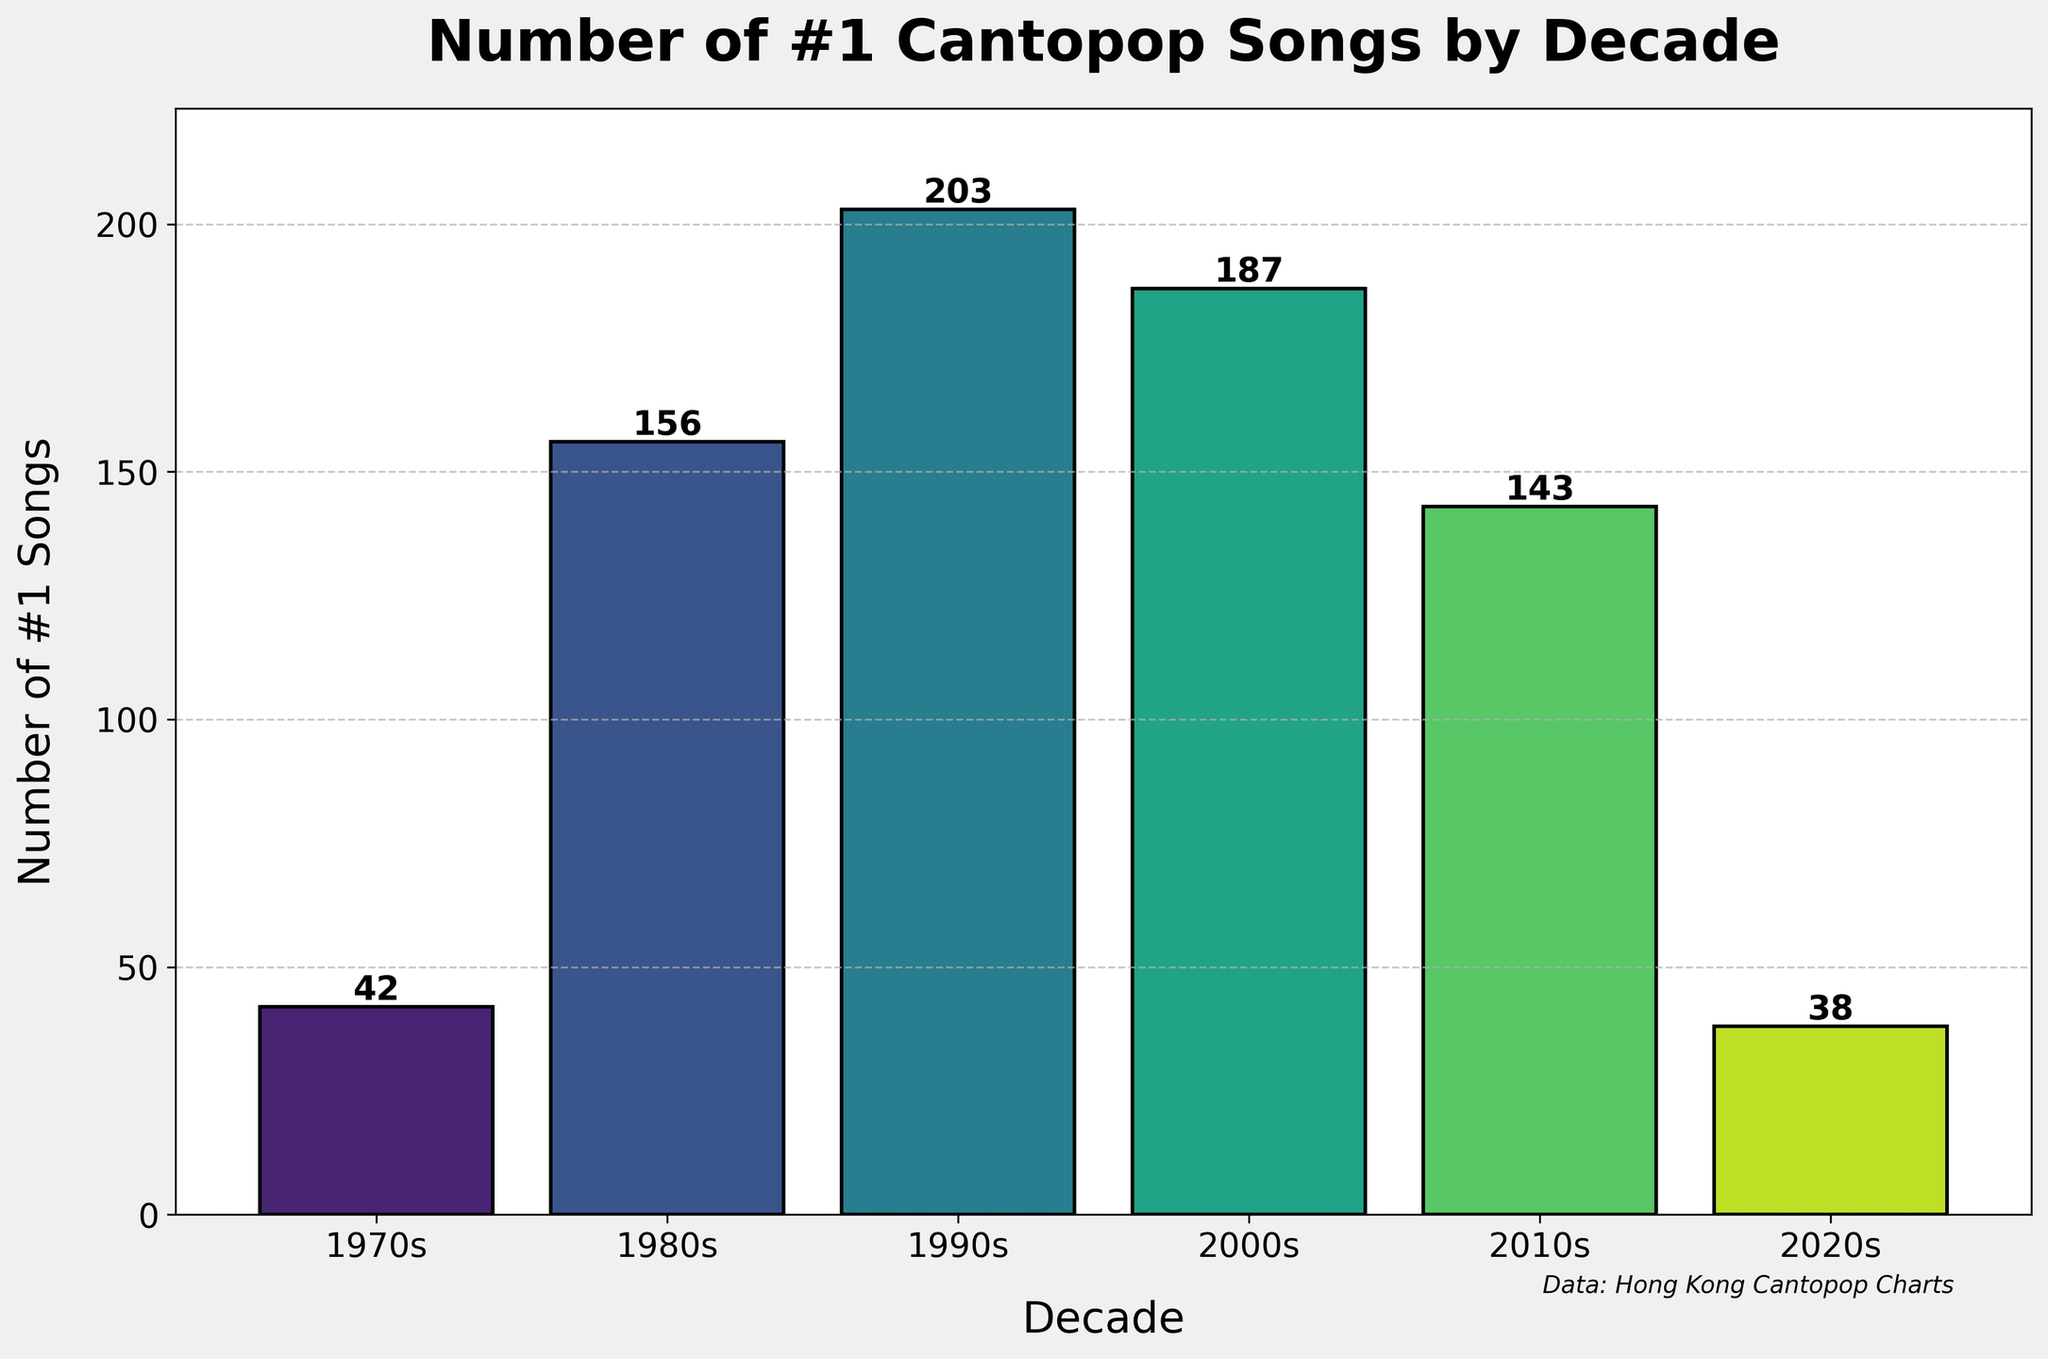Which decade had the highest number of #1 Cantopop songs? By looking at the heights of the bars, the tallest bar corresponds to the 1990s, indicating that this decade had the highest number of #1 Cantopop songs.
Answer: 1990s How many more #1 Cantopop songs were there in the 2000s compared to the 2010s? The number of #1 Cantopop songs in the 2000s is 187 and in the 2010s is 143. The difference is 187 - 143.
Answer: 44 What is the total number of #1 Cantopop songs in the 1970s, 1980s, and 1990s combined? Summing up the numbers: 42 (1970s) + 156 (1980s) + 203 (1990s).
Answer: 401 Which decade saw a greater decline in the number of #1 Cantopop songs, from the 1990s to the 2000s or from the 2000s to the 2010s? The decline from the 1990s to the 2000s is 203 - 187 = 16. The decline from the 2000s to the 2010s is 187 - 143 = 44.
Answer: From the 2000s to the 2010s What is the average number of #1 Cantopop songs per decade from the 1970s to the 2010s? Adding the numbers from each decade and dividing by the number of decades: (42 + 156 + 203 + 187 + 143) / 5.
Answer: 146.2 How many fewer #1 Cantopop songs were there in the 2020s compared to the decade with the second highest number of #1 songs? The second highest number of #1 songs is in the 2000s with 187 songs. The number in the 2020s is 38. The difference is 187 - 38.
Answer: 149 Compare the number of #1 Cantopop songs in the 1970s and the 2020s. Which decade had fewer, and by how much? The number in the 1970s is 42 and in the 2020s is 38. The difference is 42 - 38.
Answer: 2020s by 4 